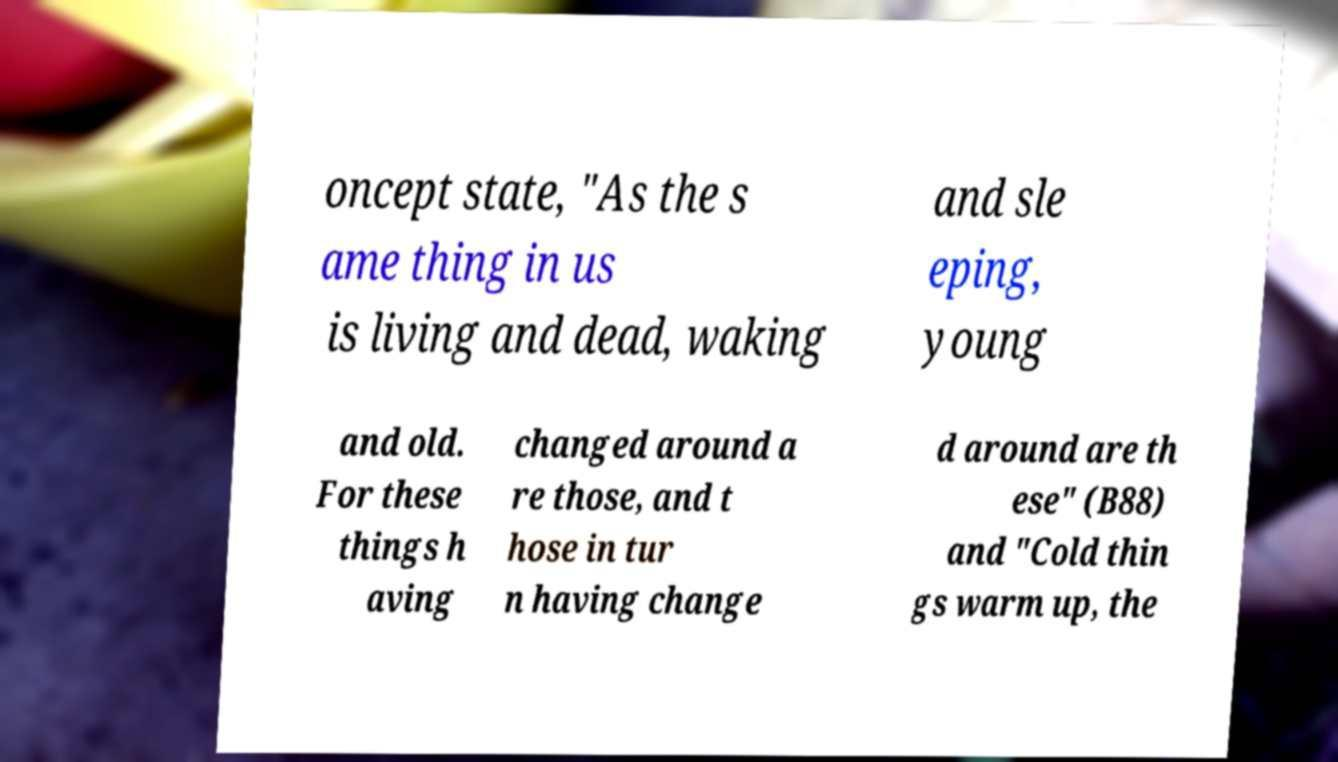Could you extract and type out the text from this image? oncept state, "As the s ame thing in us is living and dead, waking and sle eping, young and old. For these things h aving changed around a re those, and t hose in tur n having change d around are th ese" (B88) and "Cold thin gs warm up, the 